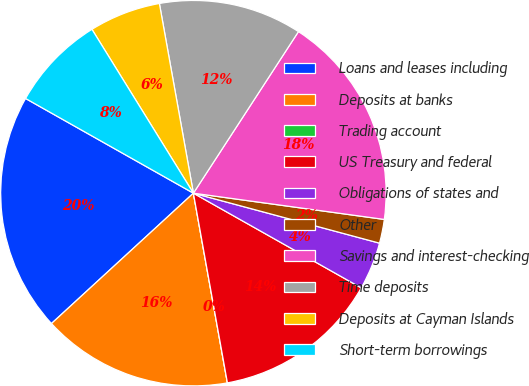<chart> <loc_0><loc_0><loc_500><loc_500><pie_chart><fcel>Loans and leases including<fcel>Deposits at banks<fcel>Trading account<fcel>US Treasury and federal<fcel>Obligations of states and<fcel>Other<fcel>Savings and interest-checking<fcel>Time deposits<fcel>Deposits at Cayman Islands<fcel>Short-term borrowings<nl><fcel>20.0%<fcel>16.0%<fcel>0.0%<fcel>14.0%<fcel>4.0%<fcel>2.0%<fcel>18.0%<fcel>12.0%<fcel>6.0%<fcel>8.0%<nl></chart> 